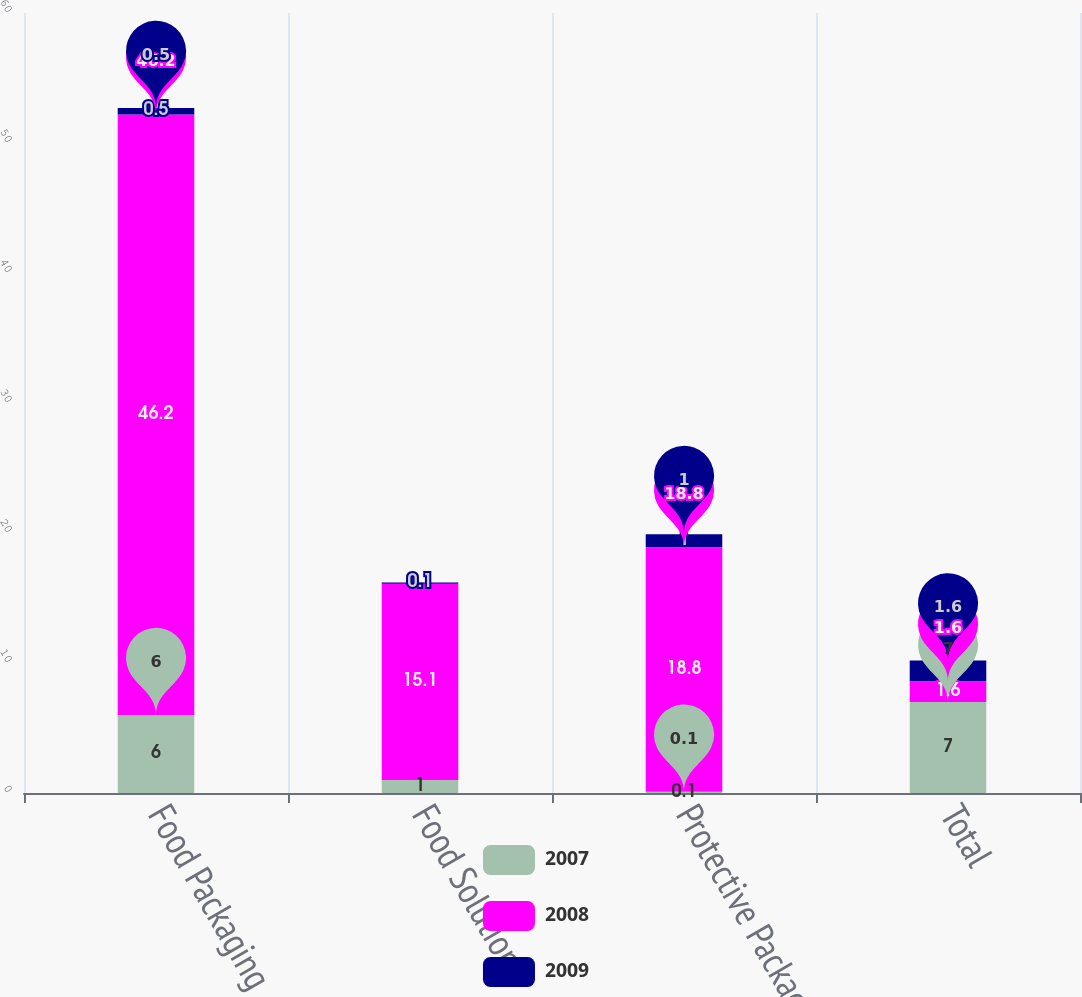Convert chart. <chart><loc_0><loc_0><loc_500><loc_500><stacked_bar_chart><ecel><fcel>Food Packaging<fcel>Food Solutions<fcel>Protective Packaging<fcel>Total<nl><fcel>2007<fcel>6<fcel>1<fcel>0.1<fcel>7<nl><fcel>2008<fcel>46.2<fcel>15.1<fcel>18.8<fcel>1.6<nl><fcel>2009<fcel>0.5<fcel>0.1<fcel>1<fcel>1.6<nl></chart> 